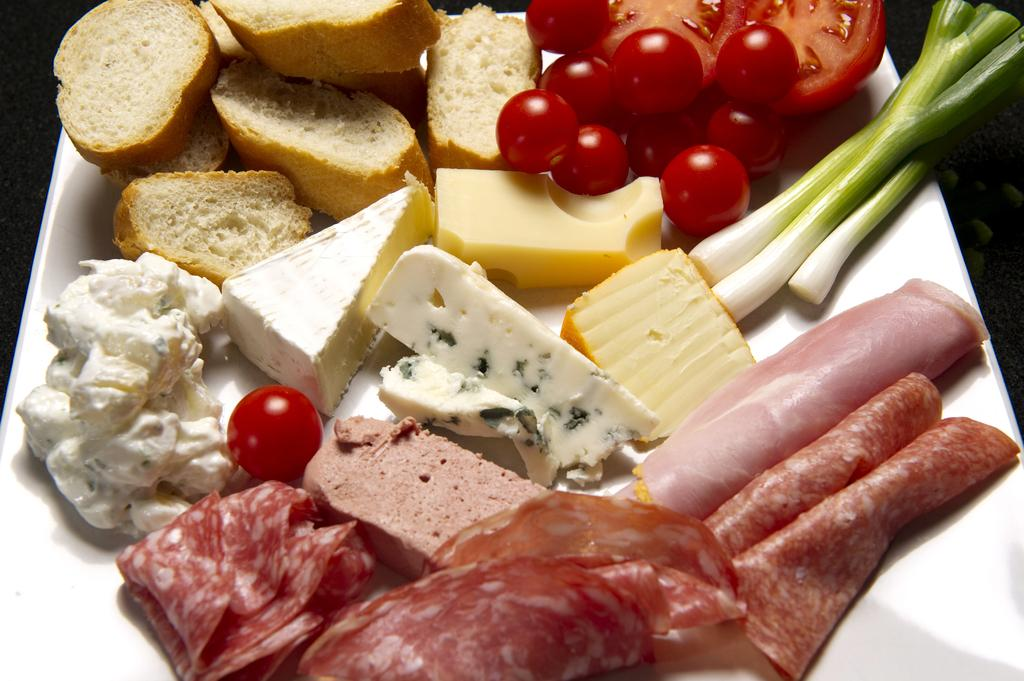What object is visible in the image that is typically used for serving food? There is a plate in the image that is typically used for serving food. What type of food can be seen on the plate? The plate contains food, including cherries, tomatoes, cheese, butter, bread, and flesh (possibly referring to meat). Can you identify any specific ingredients or components of the food on the plate? Yes, cherries, tomatoes, cheese, butter, bread, and flesh (possibly referring to meat) are present in the image. What type of cake is being served as a surprise to the ducks in the image? There is no cake, surprise or ducks present in the image. 